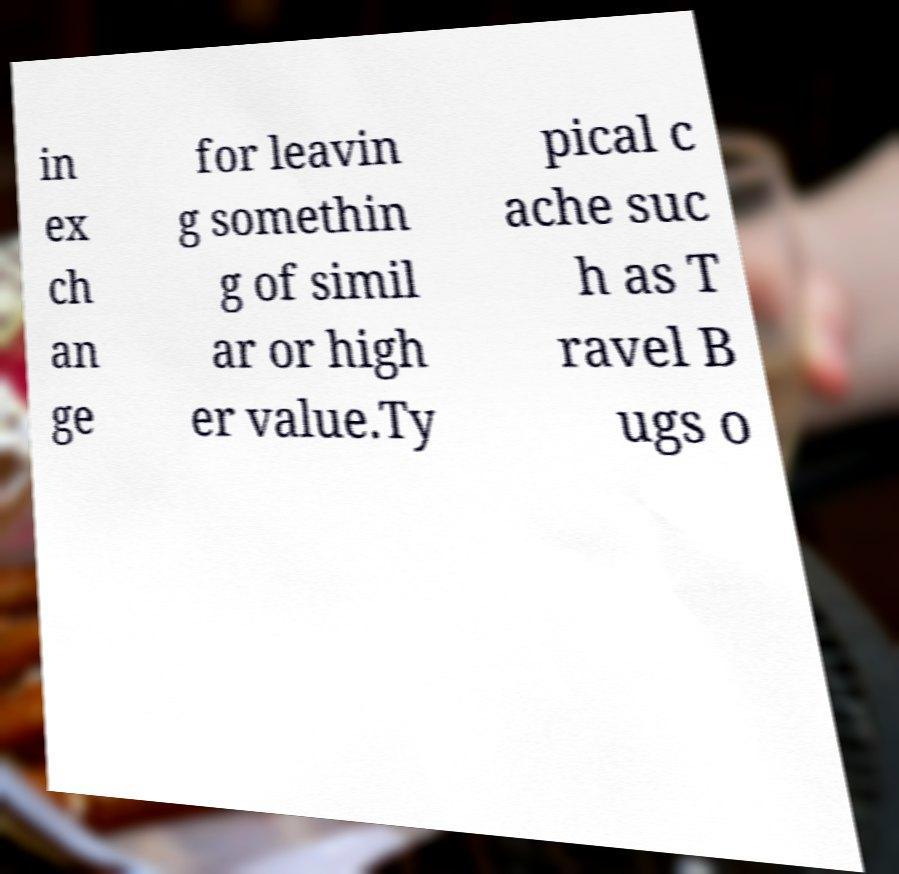Could you extract and type out the text from this image? in ex ch an ge for leavin g somethin g of simil ar or high er value.Ty pical c ache suc h as T ravel B ugs o 